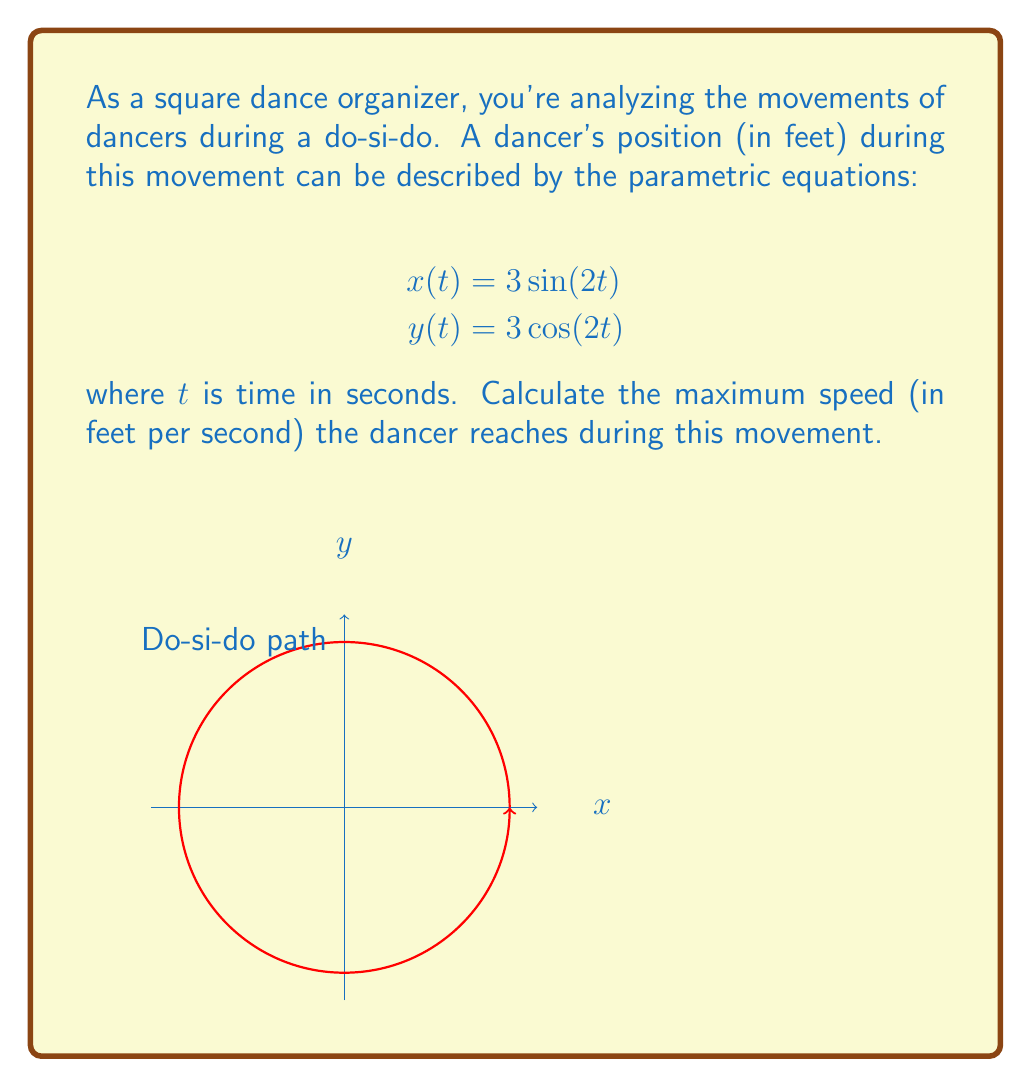Can you solve this math problem? To find the maximum speed, we need to follow these steps:

1) First, let's find the velocity components:
   $$v_x = \frac{dx}{dt} = 6\cos(2t)$$
   $$v_y = \frac{dy}{dt} = -6\sin(2t)$$

2) The speed is the magnitude of the velocity vector:
   $$\text{speed} = \sqrt{v_x^2 + v_y^2}$$

3) Substituting our velocity components:
   $$\text{speed} = \sqrt{(6\cos(2t))^2 + (-6\sin(2t))^2}$$

4) Simplify:
   $$\text{speed} = \sqrt{36\cos^2(2t) + 36\sin^2(2t)}$$
   $$\text{speed} = \sqrt{36(\cos^2(2t) + \sin^2(2t))}$$

5) Recall the trigonometric identity $\cos^2(\theta) + \sin^2(\theta) = 1$:
   $$\text{speed} = \sqrt{36 \cdot 1} = 6$$

6) The speed is constant at 6 feet per second throughout the movement.

Therefore, the maximum speed is also 6 feet per second.
Answer: 6 ft/s 